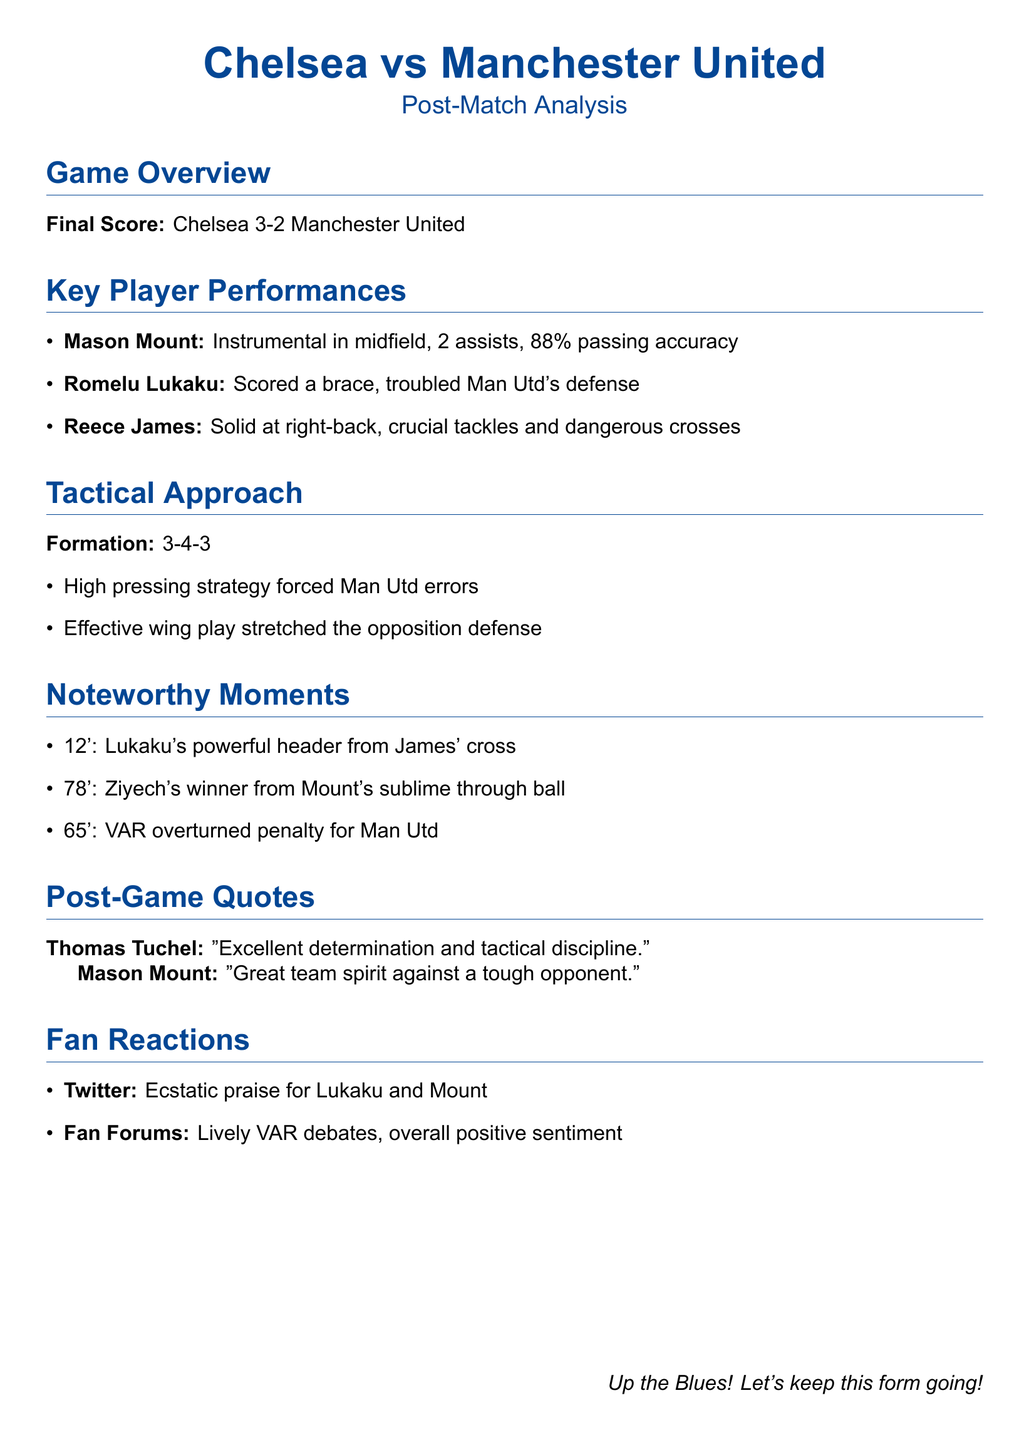what was the final score of the game? The final score is stated in the document as Chelsea 3-2 Manchester United.
Answer: Chelsea 3-2 Manchester United who assisted Lukaku's first goal? The document mentions that Lukaku's first goal came from a cross by Reece James.
Answer: Reece James how many assists did Mason Mount have? The document specifies that Mason Mount had 2 assists in the game.
Answer: 2 assists what formation did Chelsea use in the match? The document clearly states that Chelsea's formation was 3-4-3.
Answer: 3-4-3 which player scored the winning goal? According to the document, the winning goal was scored by Ziyech.
Answer: Ziyech what was the percentage of Mason Mount's passing accuracy? The document lists Mason Mount's passing accuracy as 88%.
Answer: 88% who made a comment about team spirit? Mason Mount is quoted regarding great team spirit in the document.
Answer: Mason Mount what was a notable moment involving VAR? The document mentions that VAR overturned a penalty for Manchester United.
Answer: VAR overturned penalty what did Thomas Tuchel say about the team's performance? Tuchel commented on "excellent determination and tactical discipline."
Answer: excellent determination and tactical discipline 